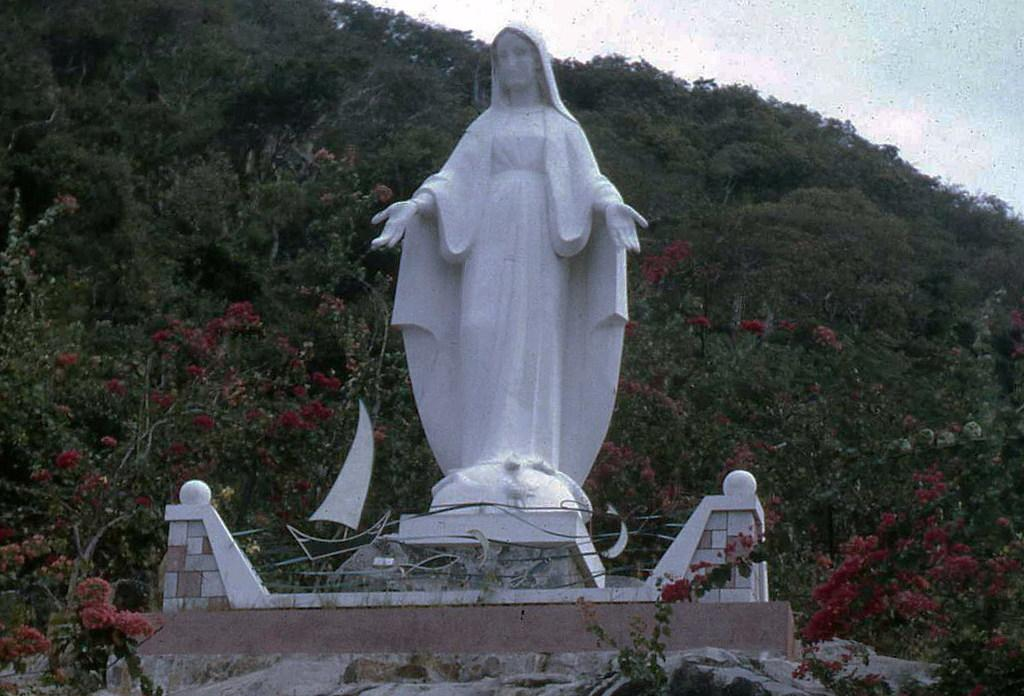What is the main subject in the image? There is a statue in the image. What can be seen surrounding the statue? There are many trees around the statue. Is there any visible steam coming from the statue in the image? No, there is no steam present in the image. 